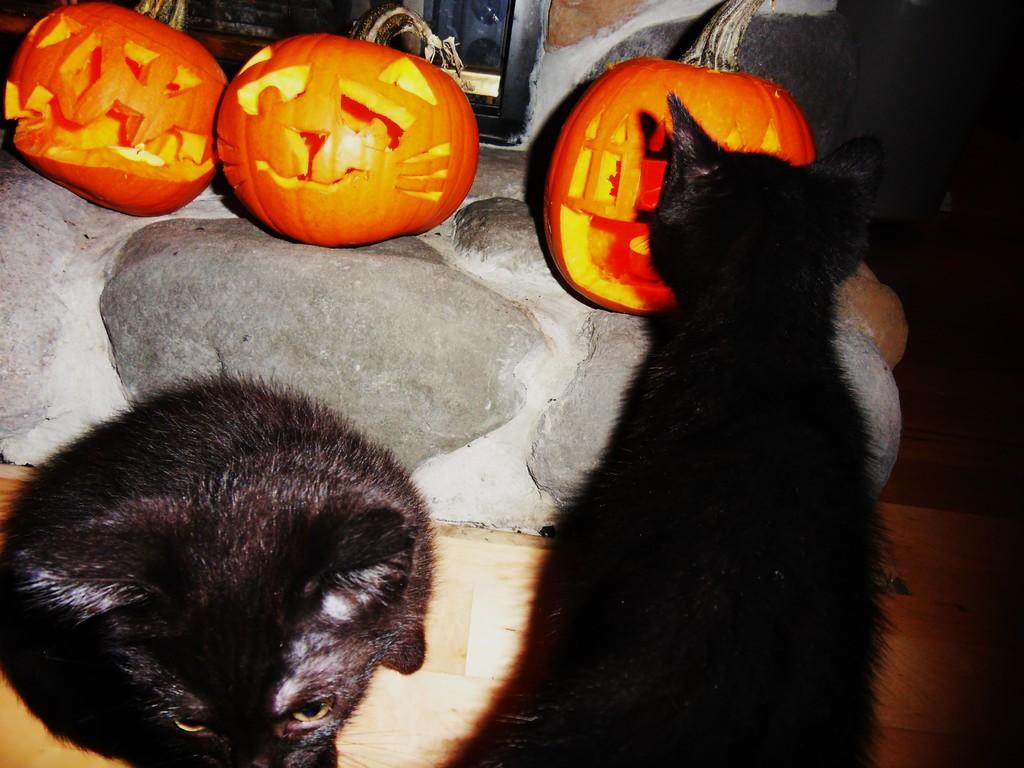How many cats are in the image? There are two cats in the image. What are the cats doing in the image? The cats are sitting on the floor. What color are the cats? The cats are black in color. What other objects are in the image besides the cats? There are three pumpkins in the image. What color are the pumpkins? The pumpkins are orange in color. Can you see the brush that the cats are using to paint the pumpkins in the image? There is no brush or painting activity depicted in the image; the cats are simply sitting on the floor and the pumpkins are orange in color. 